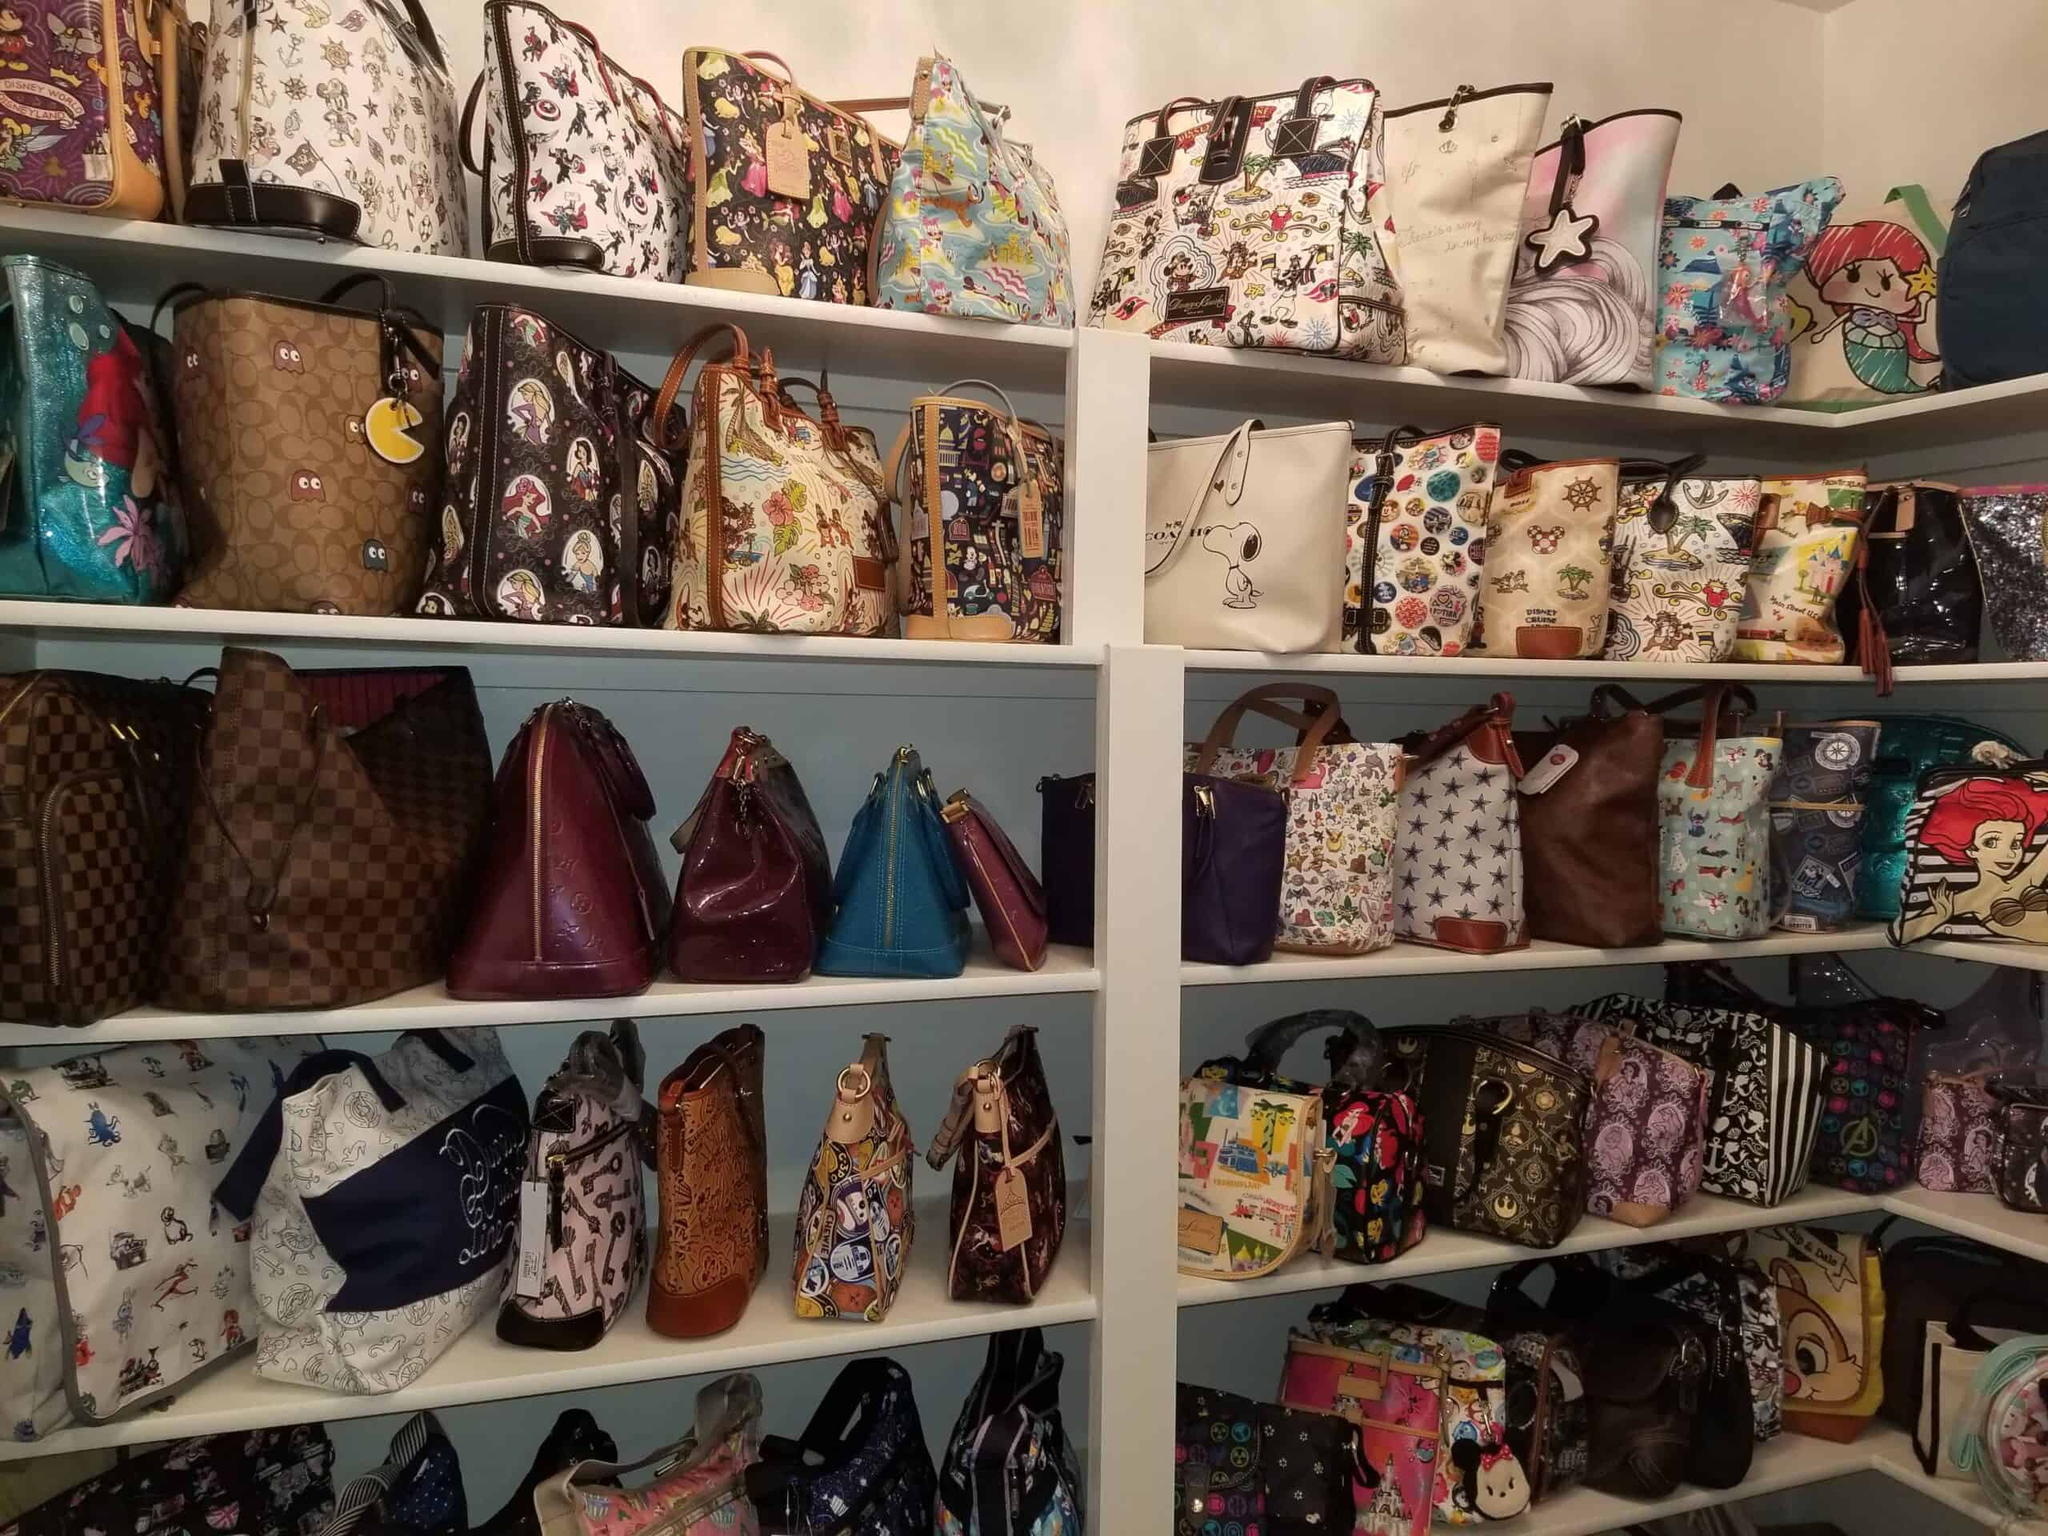Can you identify any specific characters or themes depicted on the bags? Yes, among the bags on display, you can identify various well-known characters and themes from pop culture. For instance, there are bags featuring characters like Snoopy, Ariel from 'The Little Mermaid', and other popular animated figures. These themed designs are quite striking and likely appeal to fans of these characters. 